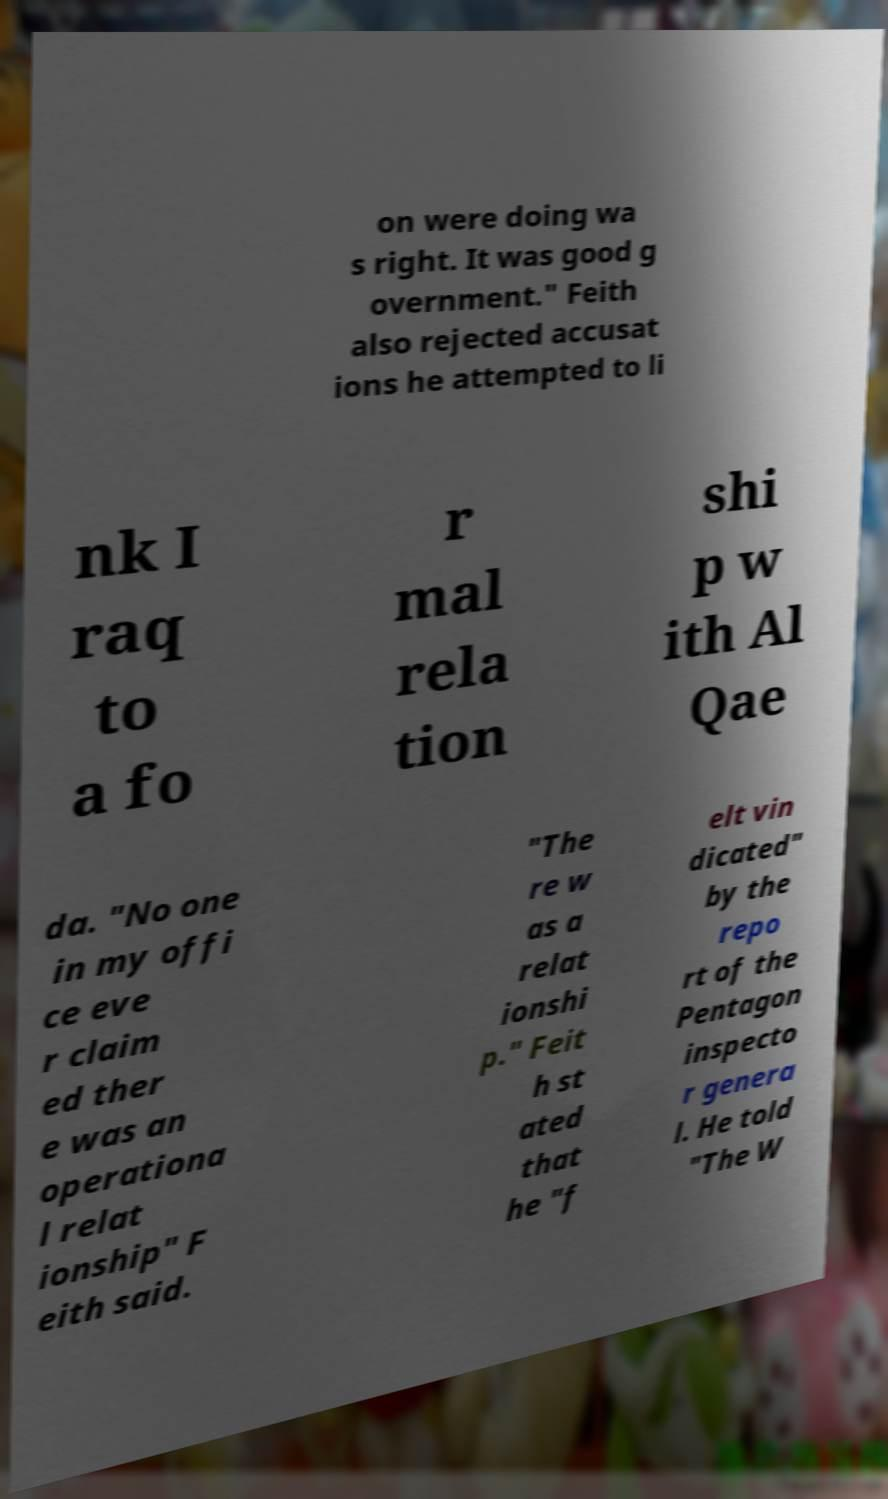Could you extract and type out the text from this image? on were doing wa s right. It was good g overnment." Feith also rejected accusat ions he attempted to li nk I raq to a fo r mal rela tion shi p w ith Al Qae da. "No one in my offi ce eve r claim ed ther e was an operationa l relat ionship" F eith said. "The re w as a relat ionshi p." Feit h st ated that he "f elt vin dicated" by the repo rt of the Pentagon inspecto r genera l. He told "The W 